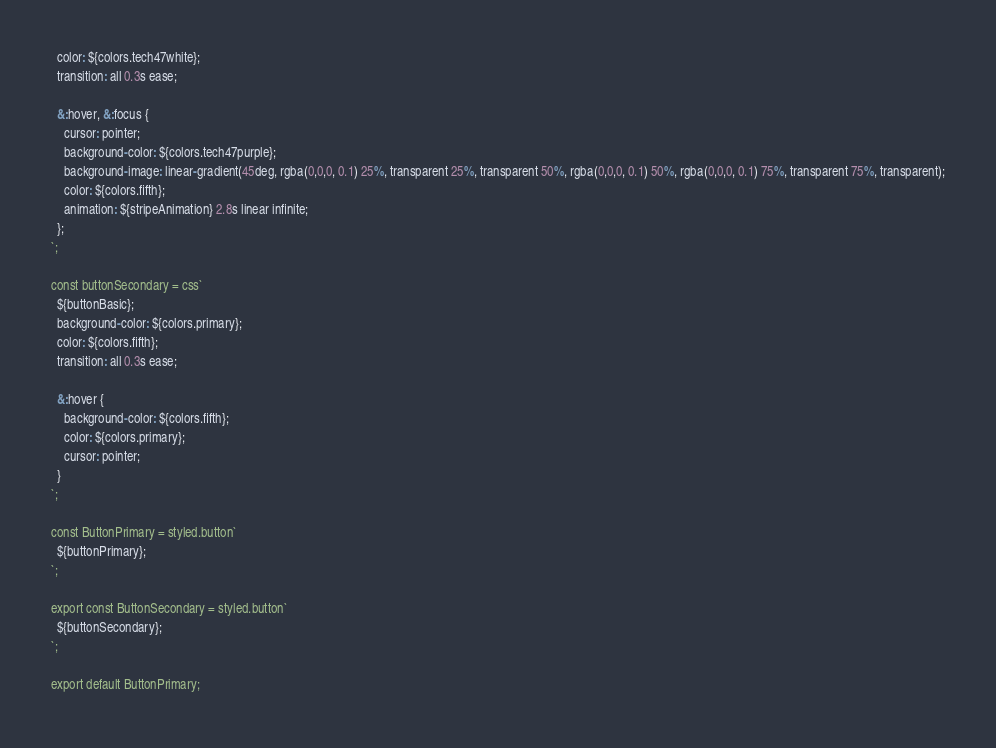Convert code to text. <code><loc_0><loc_0><loc_500><loc_500><_JavaScript_>  color: ${colors.tech47white};
  transition: all 0.3s ease;

  &:hover, &:focus {
    cursor: pointer;
    background-color: ${colors.tech47purple};
    background-image: linear-gradient(45deg, rgba(0,0,0, 0.1) 25%, transparent 25%, transparent 50%, rgba(0,0,0, 0.1) 50%, rgba(0,0,0, 0.1) 75%, transparent 75%, transparent);
    color: ${colors.fifth};
    animation: ${stripeAnimation} 2.8s linear infinite;
  };
`;

const buttonSecondary = css`
  ${buttonBasic};
  background-color: ${colors.primary};
  color: ${colors.fifth};
  transition: all 0.3s ease;

  &:hover {
    background-color: ${colors.fifth};
    color: ${colors.primary};
    cursor: pointer;
  }
`;

const ButtonPrimary = styled.button`
  ${buttonPrimary};
`;

export const ButtonSecondary = styled.button`
  ${buttonSecondary};
`;

export default ButtonPrimary;
</code> 